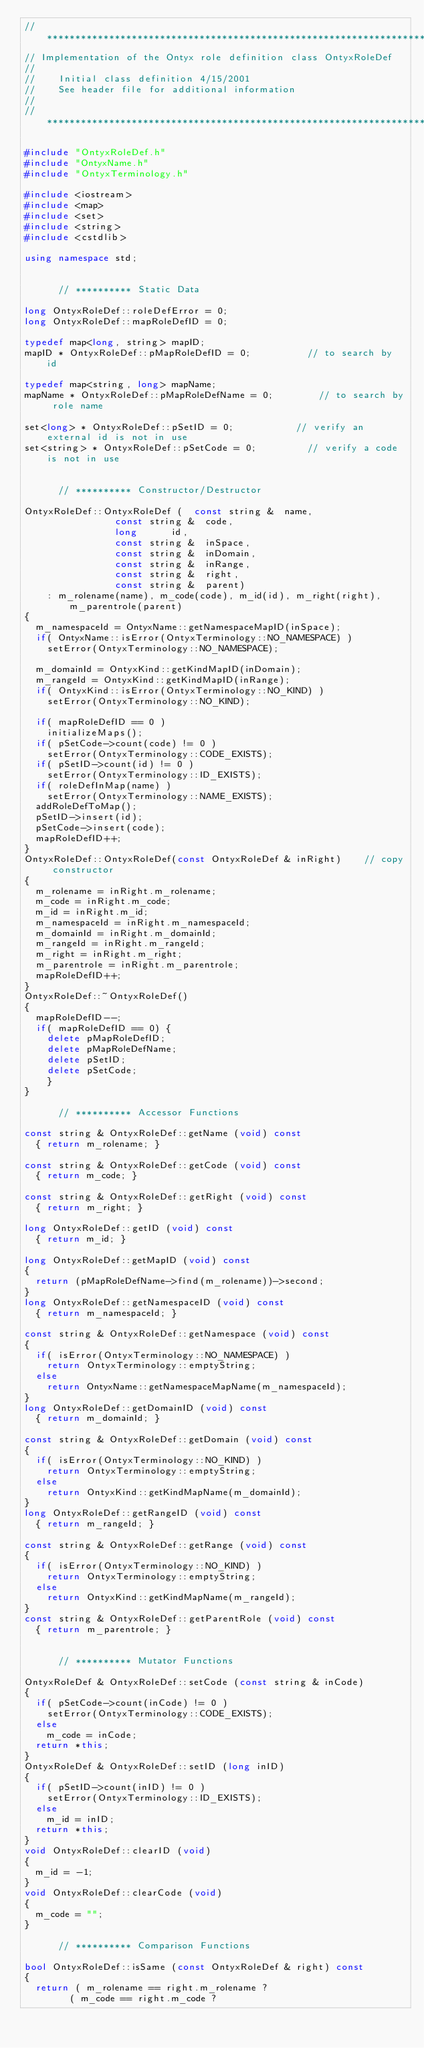<code> <loc_0><loc_0><loc_500><loc_500><_C++_>//*******************************************************************
// Implementation of the Ontyx role definition class OntyxRoleDef
//
//		Initial class definition 4/15/2001
//		See header file for additional information
//
//*******************************************************************

#include "OntyxRoleDef.h"
#include "OntyxName.h"
#include "OntyxTerminology.h"

#include <iostream>
#include <map>
#include <set>
#include <string>
#include <cstdlib>

using namespace std;


			// ********** Static Data

long OntyxRoleDef::roleDefError = 0;
long OntyxRoleDef::mapRoleDefID = 0;

typedef map<long, string> mapID;
mapID * OntyxRoleDef::pMapRoleDefID = 0;					// to search by id

typedef map<string, long> mapName;
mapName * OntyxRoleDef::pMapRoleDefName = 0;				// to search by role name

set<long> * OntyxRoleDef::pSetID = 0;						// verify an external id is not in use
set<string> * OntyxRoleDef::pSetCode = 0;					// verify a code is not in use


			// ********** Constructor/Destructor

OntyxRoleDef::OntyxRoleDef (	const string &	name, 
								const string &	code, 
								long			id,
								const string &	inSpace, 
								const string &	inDomain, 
								const string &	inRange,
								const string &	right,
								const string & 	parent)
		: m_rolename(name), m_code(code), m_id(id), m_right(right), m_parentrole(parent)
{
	m_namespaceId = OntyxName::getNamespaceMapID(inSpace);
	if( OntyxName::isError(OntyxTerminology::NO_NAMESPACE) )
		setError(OntyxTerminology::NO_NAMESPACE);

	m_domainId = OntyxKind::getKindMapID(inDomain);
	m_rangeId = OntyxKind::getKindMapID(inRange);
	if( OntyxKind::isError(OntyxTerminology::NO_KIND) )
		setError(OntyxTerminology::NO_KIND);

	if( mapRoleDefID == 0 )
		initializeMaps();
	if( pSetCode->count(code) != 0 )
		setError(OntyxTerminology::CODE_EXISTS);
	if( pSetID->count(id) != 0 )
		setError(OntyxTerminology::ID_EXISTS);
	if( roleDefInMap(name) )
		setError(OntyxTerminology::NAME_EXISTS);
	addRoleDefToMap();
	pSetID->insert(id);
	pSetCode->insert(code);
	mapRoleDefID++;
}
OntyxRoleDef::OntyxRoleDef(const OntyxRoleDef & inRight)		// copy constructor
{
	m_rolename = inRight.m_rolename;
	m_code = inRight.m_code;
	m_id = inRight.m_id;
	m_namespaceId = inRight.m_namespaceId;
	m_domainId = inRight.m_domainId;
	m_rangeId = inRight.m_rangeId;
	m_right = inRight.m_right;
	m_parentrole = inRight.m_parentrole;
	mapRoleDefID++;
}
OntyxRoleDef::~OntyxRoleDef()
{
	mapRoleDefID--;
	if( mapRoleDefID == 0) {
		delete pMapRoleDefID;
		delete pMapRoleDefName;
		delete pSetID;
		delete pSetCode;
		}
}

			// ********** Accessor Functions

const string & OntyxRoleDef::getName (void) const
	{ return m_rolename; }

const string & OntyxRoleDef::getCode (void) const
	{ return m_code; }

const string & OntyxRoleDef::getRight (void) const
	{ return m_right; }

long OntyxRoleDef::getID (void) const
	{ return m_id; }

long OntyxRoleDef::getMapID (void) const
{
	return (pMapRoleDefName->find(m_rolename))->second;
}
long OntyxRoleDef::getNamespaceID (void) const
	{ return m_namespaceId; }

const string & OntyxRoleDef::getNamespace (void) const
{
	if( isError(OntyxTerminology::NO_NAMESPACE) )
		return OntyxTerminology::emptyString;
	else
		return OntyxName::getNamespaceMapName(m_namespaceId);
}
long OntyxRoleDef::getDomainID (void) const
	{ return m_domainId; }

const string & OntyxRoleDef::getDomain (void) const
{
	if( isError(OntyxTerminology::NO_KIND) )
		return OntyxTerminology::emptyString;
	else
		return OntyxKind::getKindMapName(m_domainId);
}
long OntyxRoleDef::getRangeID (void) const
	{ return m_rangeId; }

const string & OntyxRoleDef::getRange (void) const
{
	if( isError(OntyxTerminology::NO_KIND) )
		return OntyxTerminology::emptyString;
	else
		return OntyxKind::getKindMapName(m_rangeId);
}
const string & OntyxRoleDef::getParentRole (void) const
	{ return m_parentrole; }
	

			// ********** Mutator Functions

OntyxRoleDef & OntyxRoleDef::setCode (const string & inCode)
{
	if( pSetCode->count(inCode) != 0 )
		setError(OntyxTerminology::CODE_EXISTS);
	else
		m_code = inCode;
	return *this;
}
OntyxRoleDef & OntyxRoleDef::setID (long inID)
{
	if( pSetID->count(inID) != 0 )
		setError(OntyxTerminology::ID_EXISTS);
	else
		m_id = inID;
	return *this;
}
void OntyxRoleDef::clearID (void)
{
	m_id = -1;
}
void OntyxRoleDef::clearCode (void)
{
	m_code = "";
}

			// ********** Comparison Functions

bool OntyxRoleDef::isSame (const OntyxRoleDef & right) const
{
	return ( m_rolename == right.m_rolename ?
				( m_code == right.m_code ?</code> 